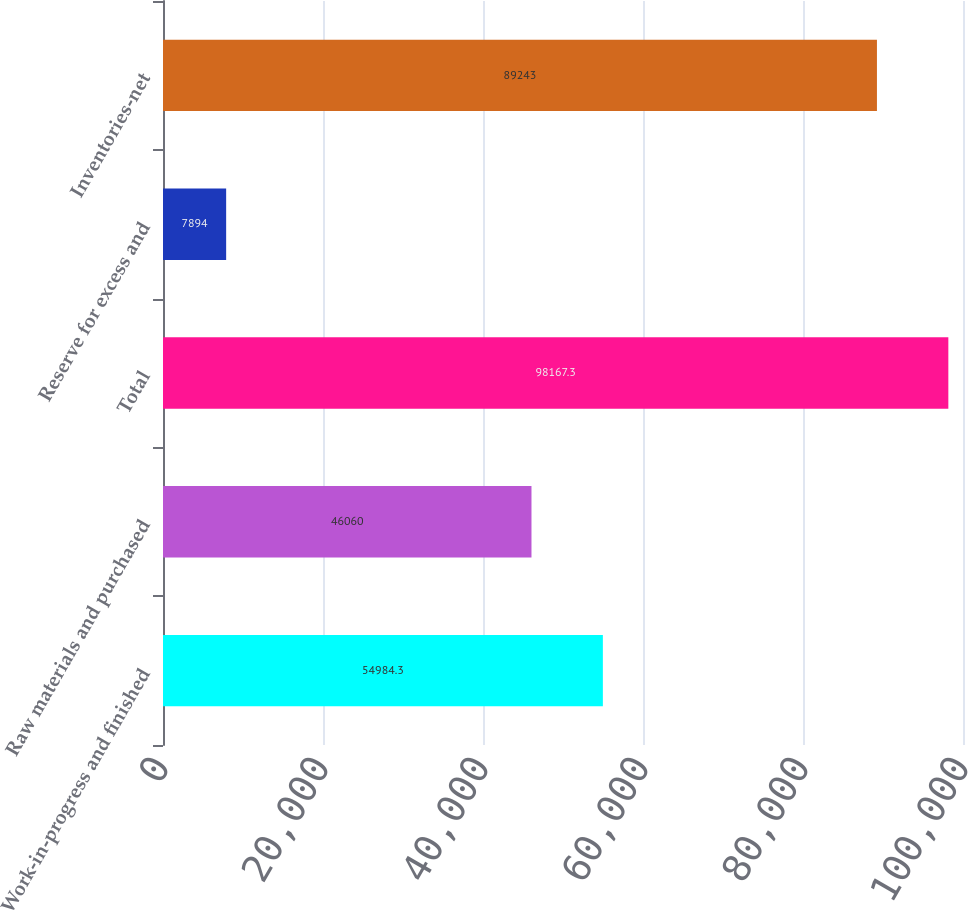Convert chart. <chart><loc_0><loc_0><loc_500><loc_500><bar_chart><fcel>Work-in-progress and finished<fcel>Raw materials and purchased<fcel>Total<fcel>Reserve for excess and<fcel>Inventories-net<nl><fcel>54984.3<fcel>46060<fcel>98167.3<fcel>7894<fcel>89243<nl></chart> 